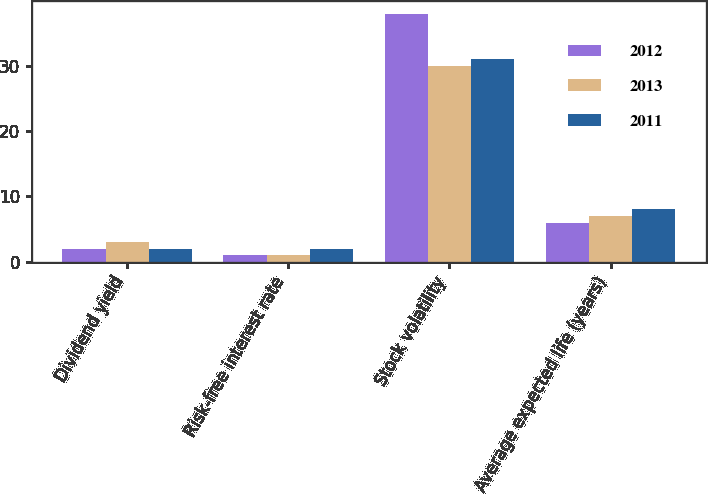<chart> <loc_0><loc_0><loc_500><loc_500><stacked_bar_chart><ecel><fcel>Dividend yield<fcel>Risk-free interest rate<fcel>Stock volatility<fcel>Average expected life (years)<nl><fcel>2012<fcel>2<fcel>1<fcel>38<fcel>6<nl><fcel>2013<fcel>3<fcel>1<fcel>30<fcel>7<nl><fcel>2011<fcel>2<fcel>2<fcel>31<fcel>8<nl></chart> 